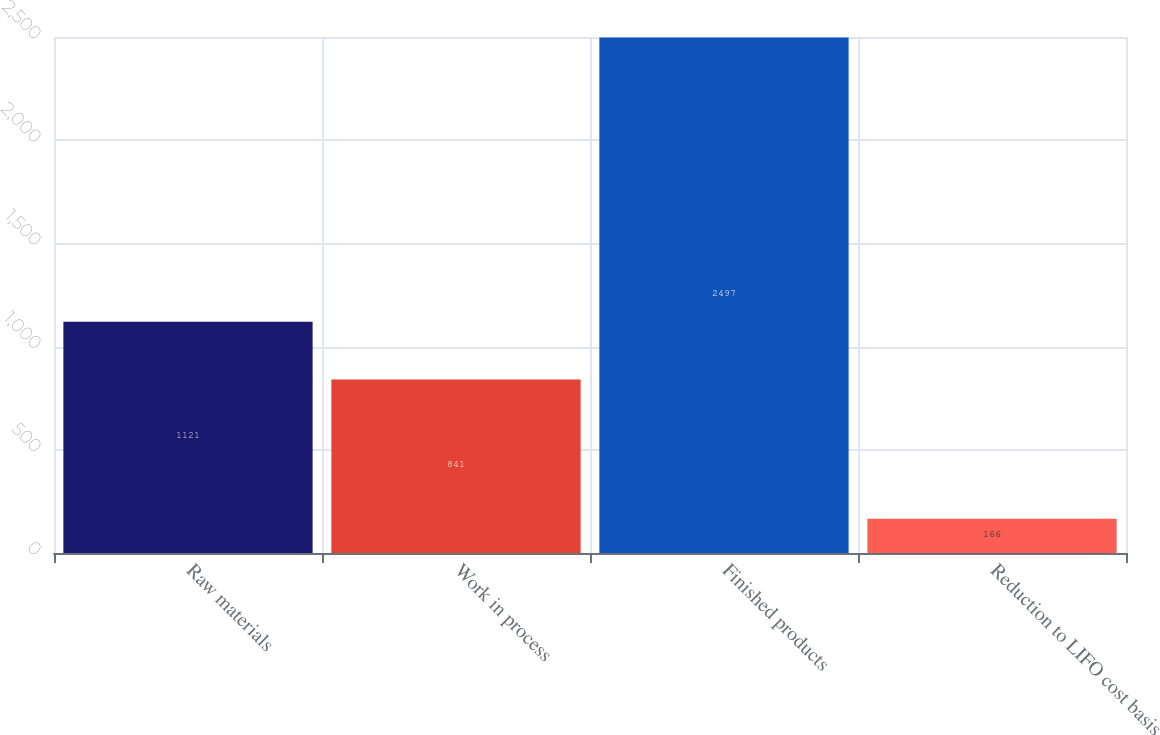Convert chart. <chart><loc_0><loc_0><loc_500><loc_500><bar_chart><fcel>Raw materials<fcel>Work in process<fcel>Finished products<fcel>Reduction to LIFO cost basis<nl><fcel>1121<fcel>841<fcel>2497<fcel>166<nl></chart> 